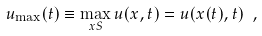<formula> <loc_0><loc_0><loc_500><loc_500>u _ { \max } ( t ) \equiv \max _ { x S } u ( x , t ) = u ( x ( t ) , t ) \ ,</formula> 